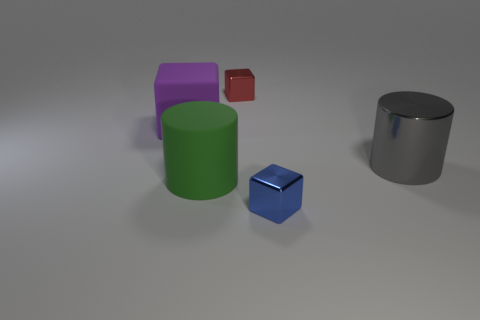Subtract all small metal cubes. How many cubes are left? 1 Add 3 gray things. How many objects exist? 8 Subtract all cylinders. How many objects are left? 3 Subtract all gray metal cubes. Subtract all large gray shiny cylinders. How many objects are left? 4 Add 1 red metal objects. How many red metal objects are left? 2 Add 4 big rubber cubes. How many big rubber cubes exist? 5 Subtract 0 red balls. How many objects are left? 5 